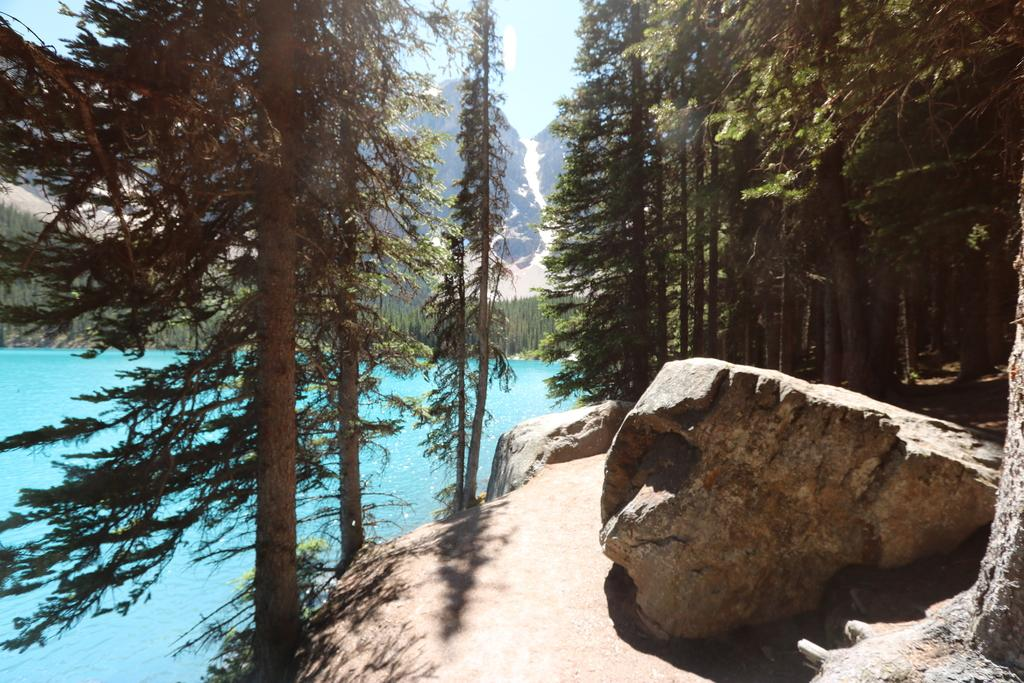What is located in the center of the image? There are trees in the center of the image. What is at the bottom of the image? There is a rock at the bottom of the image. What can be seen on the left side of the image? There is water visible on the left side of the image. What is visible in the background of the image? There are hills and the sky visible in the background of the image. Can you tell me how many buttons are on the pig in the image? There is no pig or buttons present in the image. What color is the elbow of the person in the image? There is no person or elbow present in the image. 